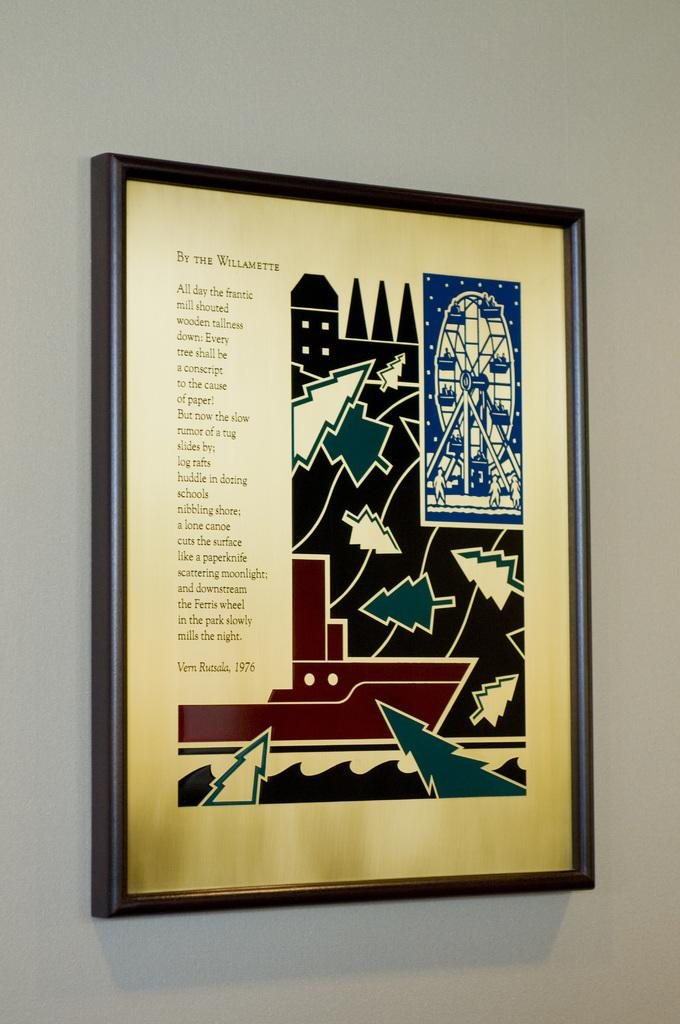What is the main subject of the image? There is a photo in the image. Where is the photo located? The photo is attached to a white wall. What can be seen on the photo frame? The photo frame has designs of trees and other designs. Is there any text on the photo frame? Yes, there is writing on the photo frame. What type of arm is visible in the photo frame? There is no arm visible in the photo frame; it only contains a photo and designs on the frame. What color is the notebook covering the photo frame? There is no notebook present in the image; it only features a photo, a white wall, and a photo frame with designs and writing. 